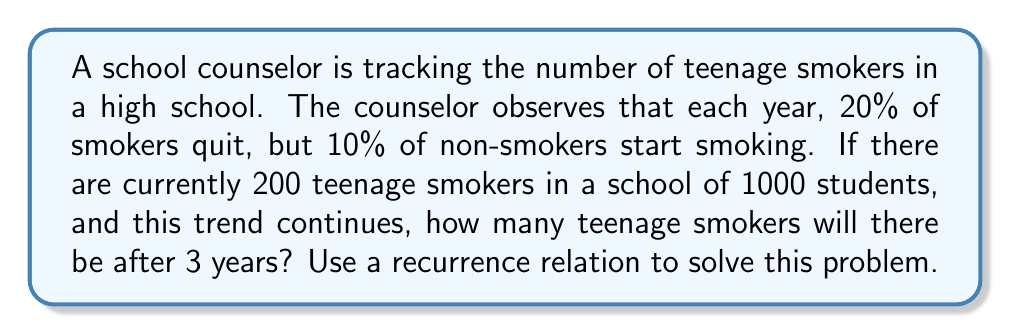Provide a solution to this math problem. Let's approach this step-by-step:

1) Let $S_n$ be the number of smokers in year $n$, where $n = 0$ is the current year.

2) We can set up a recurrence relation:
   $S_{n+1} = 0.8S_n + 0.1(1000 - S_n)$
   This means that next year's smokers will be 80% of this year's smokers, plus 10% of the non-smokers.

3) Simplify the recurrence relation:
   $S_{n+1} = 0.8S_n + 100 - 0.1S_n = 0.7S_n + 100$

4) Now we have the recurrence relation: $S_{n+1} = 0.7S_n + 100$ with initial condition $S_0 = 200$

5) Let's calculate for 3 years:

   Year 1: $S_1 = 0.7(200) + 100 = 240$
   Year 2: $S_2 = 0.7(240) + 100 = 268$
   Year 3: $S_3 = 0.7(268) + 100 = 287.6$

6) Since we can't have a fractional number of smokers, we round to the nearest whole number: 288.
Answer: After 3 years, there will be approximately 288 teenage smokers in the school. 